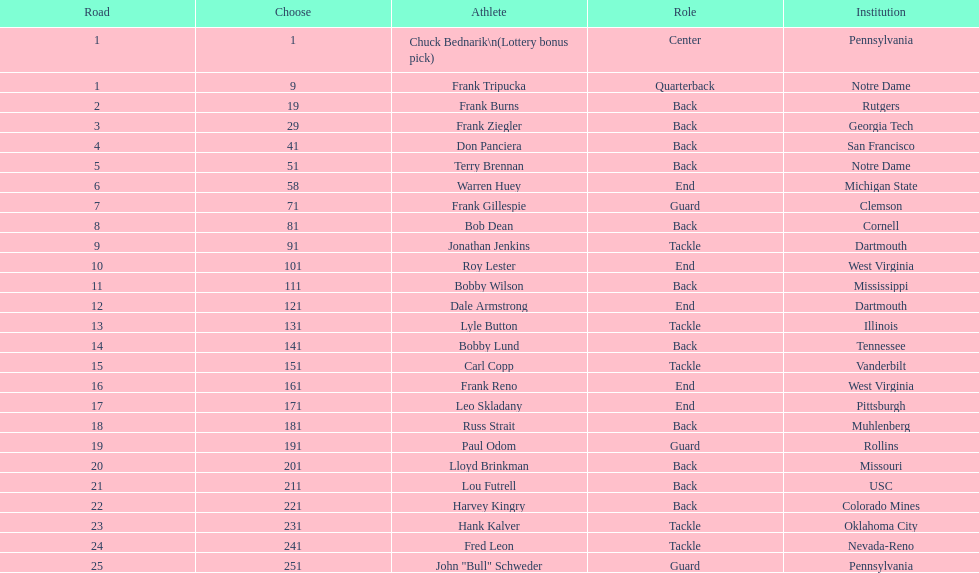Was chuck bednarik or frank tripucka the first draft pick? Chuck Bednarik. 